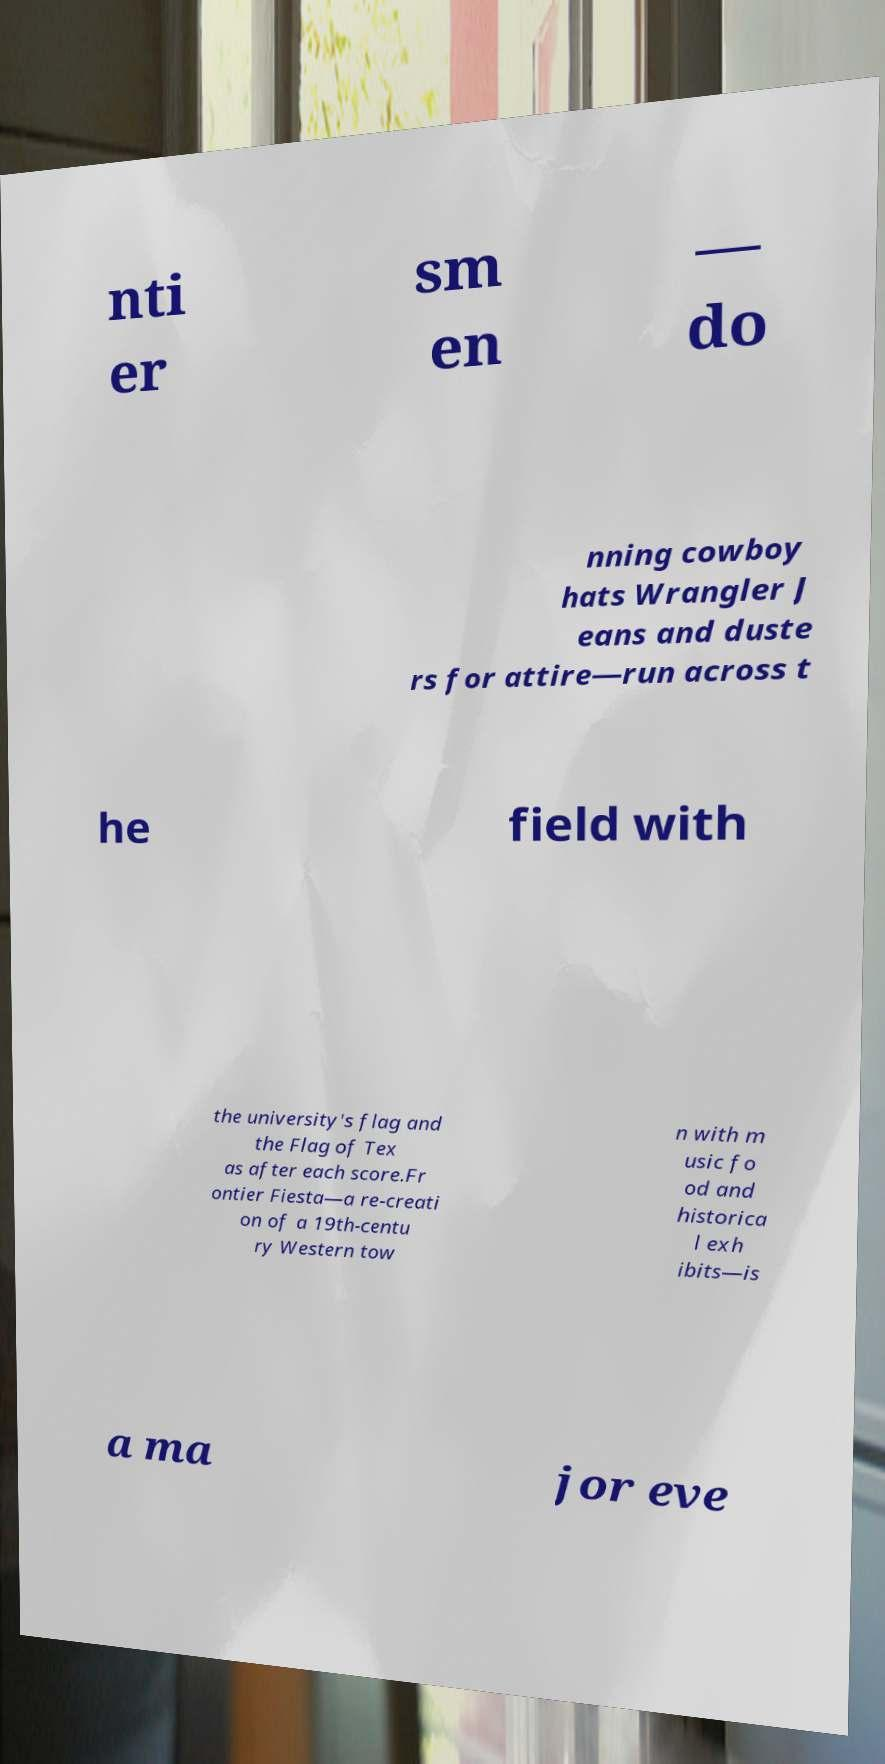Please read and relay the text visible in this image. What does it say? nti er sm en — do nning cowboy hats Wrangler J eans and duste rs for attire—run across t he field with the university's flag and the Flag of Tex as after each score.Fr ontier Fiesta—a re-creati on of a 19th-centu ry Western tow n with m usic fo od and historica l exh ibits—is a ma jor eve 